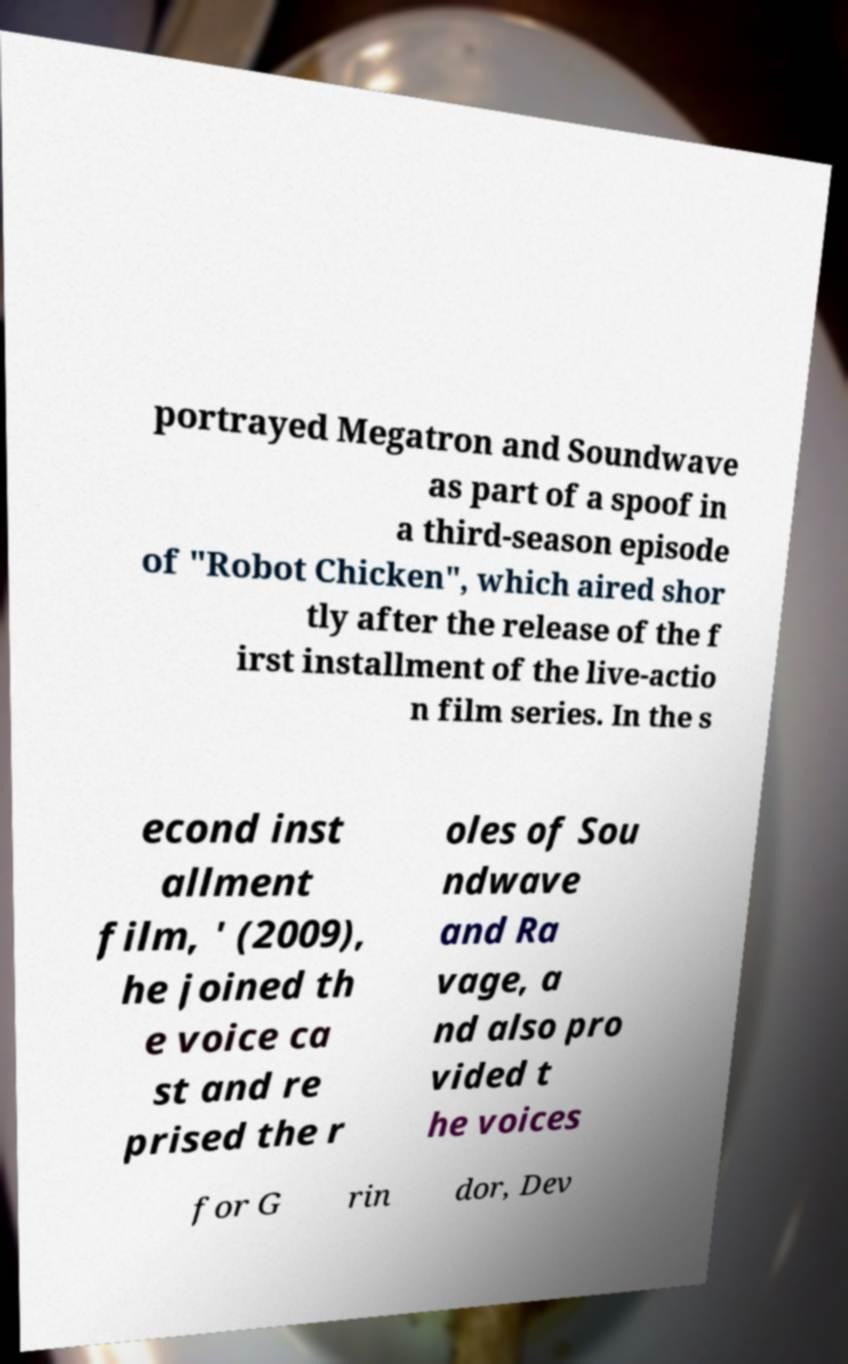Can you read and provide the text displayed in the image?This photo seems to have some interesting text. Can you extract and type it out for me? portrayed Megatron and Soundwave as part of a spoof in a third-season episode of "Robot Chicken", which aired shor tly after the release of the f irst installment of the live-actio n film series. In the s econd inst allment film, ' (2009), he joined th e voice ca st and re prised the r oles of Sou ndwave and Ra vage, a nd also pro vided t he voices for G rin dor, Dev 